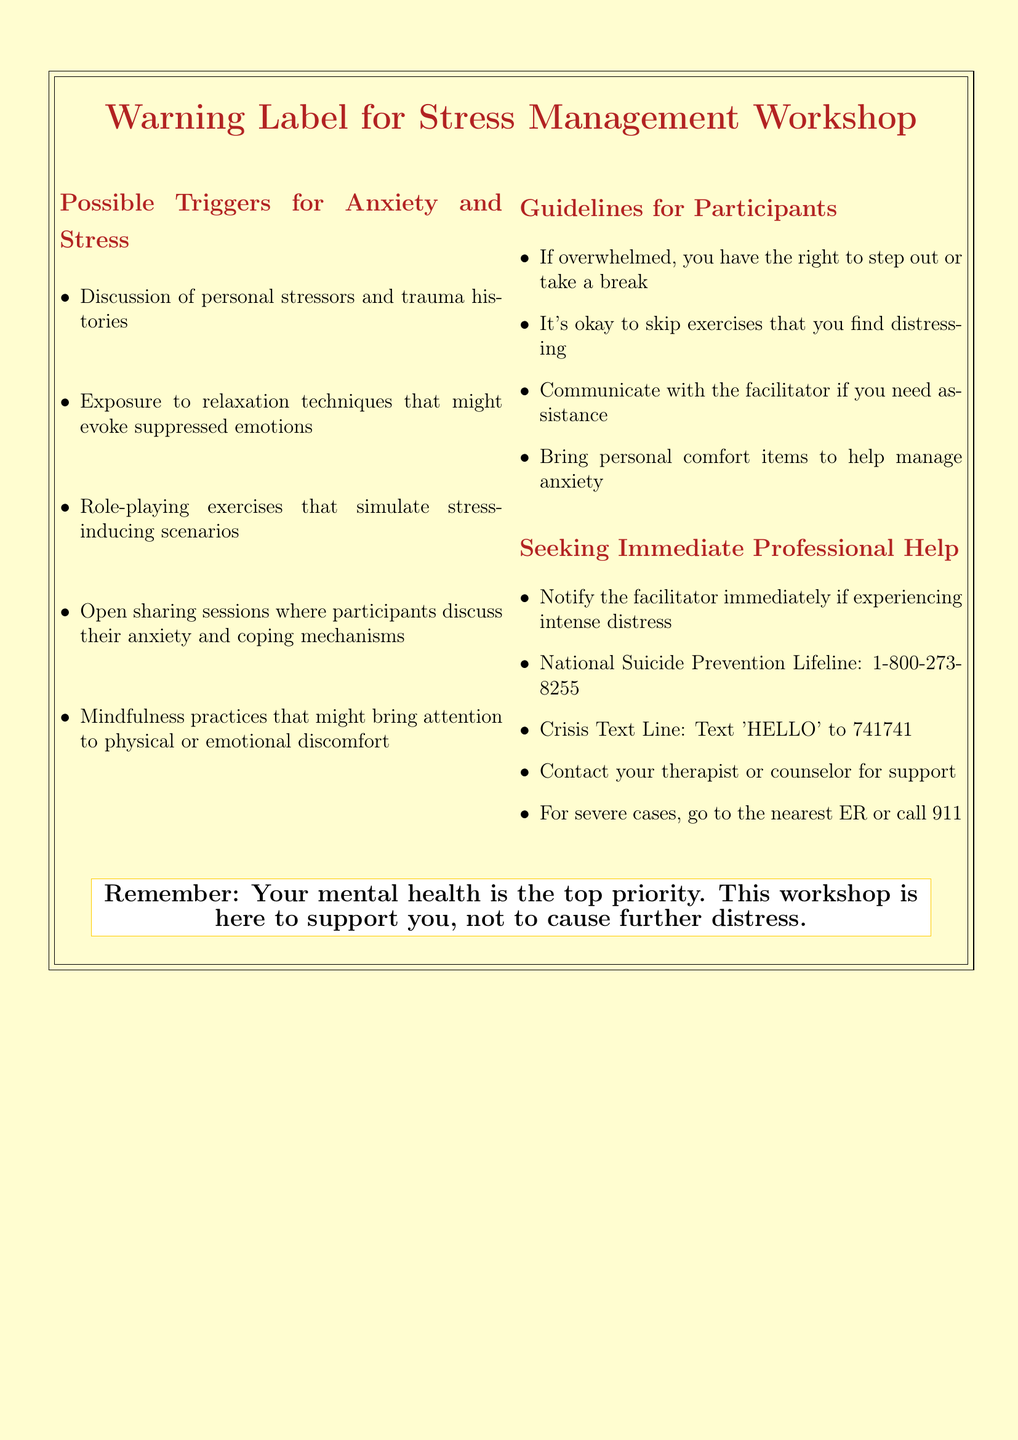What is the title of the document? The title of the document is presented prominently at the top, indicating the focus of the content.
Answer: Warning Label for Stress Management Workshop What should participants do if they feel overwhelmed? The document advises participants on how to manage their distress during the workshop, highlighting their rights.
Answer: Step out or take a break What is the contact number for the National Suicide Prevention Lifeline? The document includes a specific number that participants can call for immediate help.
Answer: 1-800-273-8255 What type of exercises might simulate stress-inducing scenarios? The document lists specific activities that could trigger stress, including particular types of exercises.
Answer: Role-playing exercises What is a guideline regarding personal comfort items? The guidelines in the document encourage participants to bring certain items for their well-being.
Answer: Bring personal comfort items to help manage anxiety What is the recommended action if someone is experiencing intense distress? The document provides specific instructions for participants who are in a state of emergency during the workshop.
Answer: Notify the facilitator immediately if experiencing intense distress 